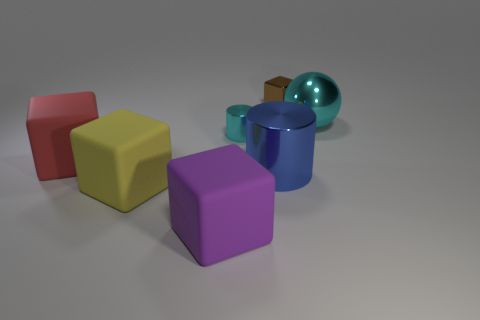Subtract all red matte cubes. How many cubes are left? 3 Subtract all yellow blocks. How many blocks are left? 3 Add 3 large red metal objects. How many objects exist? 10 Subtract 0 gray spheres. How many objects are left? 7 Subtract all cubes. How many objects are left? 3 Subtract 3 cubes. How many cubes are left? 1 Subtract all purple cubes. Subtract all cyan balls. How many cubes are left? 3 Subtract all green blocks. How many yellow spheres are left? 0 Subtract all blue objects. Subtract all big red things. How many objects are left? 5 Add 6 purple blocks. How many purple blocks are left? 7 